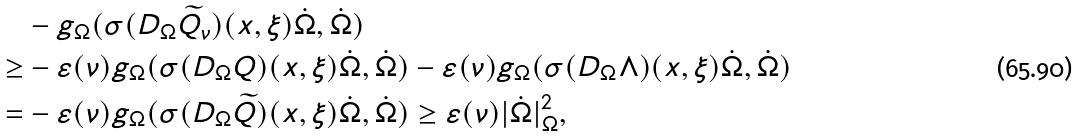<formula> <loc_0><loc_0><loc_500><loc_500>& - g _ { \Omega } ( \sigma ( D _ { \Omega } \widetilde { Q } _ { \nu } ) ( x , \xi ) \dot { \Omega } , \dot { \Omega } ) \\ \geq & - \varepsilon ( \nu ) g _ { \Omega } ( \sigma ( D _ { \Omega } Q ) ( x , \xi ) \dot { \Omega } , \dot { \Omega } ) - \varepsilon ( \nu ) g _ { \Omega } ( \sigma ( D _ { \Omega } \Lambda ) ( x , \xi ) \dot { \Omega } , \dot { \Omega } ) \\ = & - \varepsilon ( \nu ) g _ { \Omega } ( \sigma ( D _ { \Omega } \widetilde { Q } ) ( x , \xi ) \dot { \Omega } , \dot { \Omega } ) \geq \varepsilon ( \nu ) | \dot { \Omega } | _ { \Omega } ^ { 2 } ,</formula> 